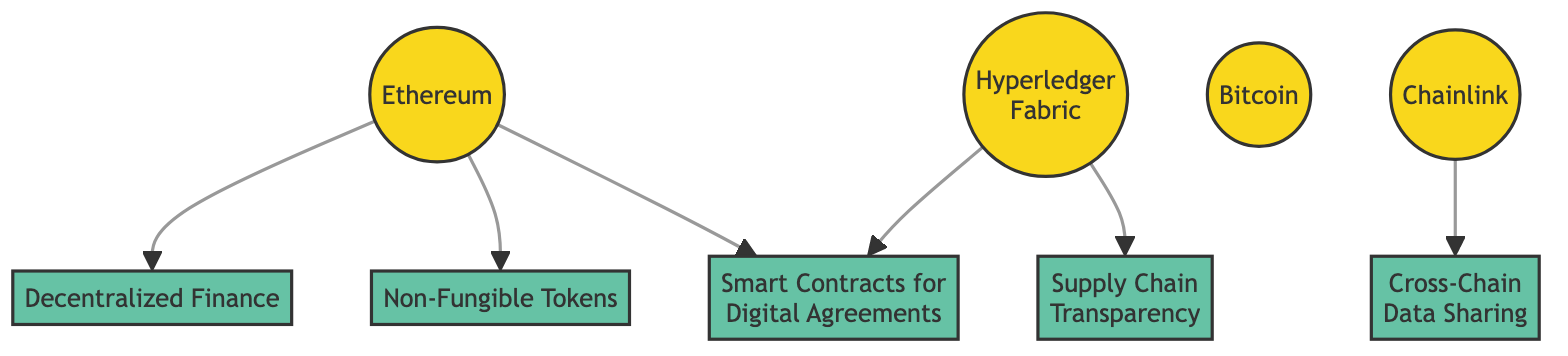What is the first blockchain technology listed in the diagram? The diagram lists the blockchain technologies in order, with Ethereum being the first one shown.
Answer: Ethereum Which application is related to Hyperledger Fabric? Hyperledger Fabric is connected to both Supply Chain Transparency and Smart Contracts for Digital Agreements, making them related applications.
Answer: Supply Chain Transparency How many total blockchain technologies are represented in the diagram? Upon counting, there are four distinct blockchain technologies represented: Ethereum, Hyperledger Fabric, Bitcoin, and Chainlink.
Answer: 4 What application is linked to Chainlink? The only application connected to Chainlink in the diagram is Cross-Chain Data Sharing, indicating its specific use case.
Answer: Cross-Chain Data Sharing Which two blockchain technologies are used for Smart Contracts? The diagram shows that both Ethereum and Hyperledger Fabric are connected to Smart Contracts for Digital Agreements, indicating they both support this application.
Answer: Ethereum, Hyperledger Fabric What type of application is Decentralized Finance (DeFi)? In the context of the diagram, DeFi is categorized as an application, specifically representing its use case within blockchain technologies.
Answer: Application How many applications are directly related to Ethereum? Analyzing the diagram, Ethereum is directly related to three applications: Decentralized Finance, Non-Fungible Tokens, and Smart Contracts for Digital Agreements.
Answer: 3 Which blockchain technology is associated with the application of Supply Chain Transparency? The diagram clearly indicates that Supply Chain Transparency is associated with Hyperledger Fabric, which specializes in this application area.
Answer: Hyperledger Fabric What is the relationship between Chainlink and the application it supports? Chainlink is directly connected to the application of Cross-Chain Data Sharing, demonstrating its role in facilitating data integration across different blockchains.
Answer: Cross-Chain Data Sharing 